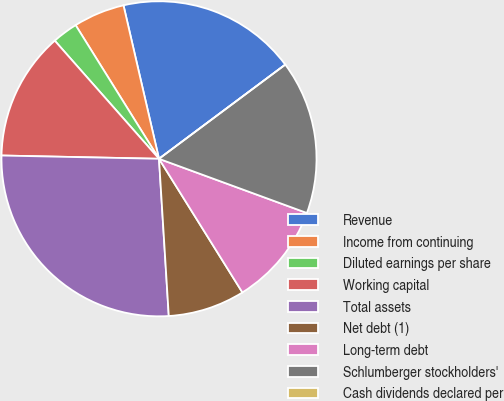Convert chart to OTSL. <chart><loc_0><loc_0><loc_500><loc_500><pie_chart><fcel>Revenue<fcel>Income from continuing<fcel>Diluted earnings per share<fcel>Working capital<fcel>Total assets<fcel>Net debt (1)<fcel>Long-term debt<fcel>Schlumberger stockholders'<fcel>Cash dividends declared per<nl><fcel>18.42%<fcel>5.26%<fcel>2.63%<fcel>13.16%<fcel>26.32%<fcel>7.89%<fcel>10.53%<fcel>15.79%<fcel>0.0%<nl></chart> 